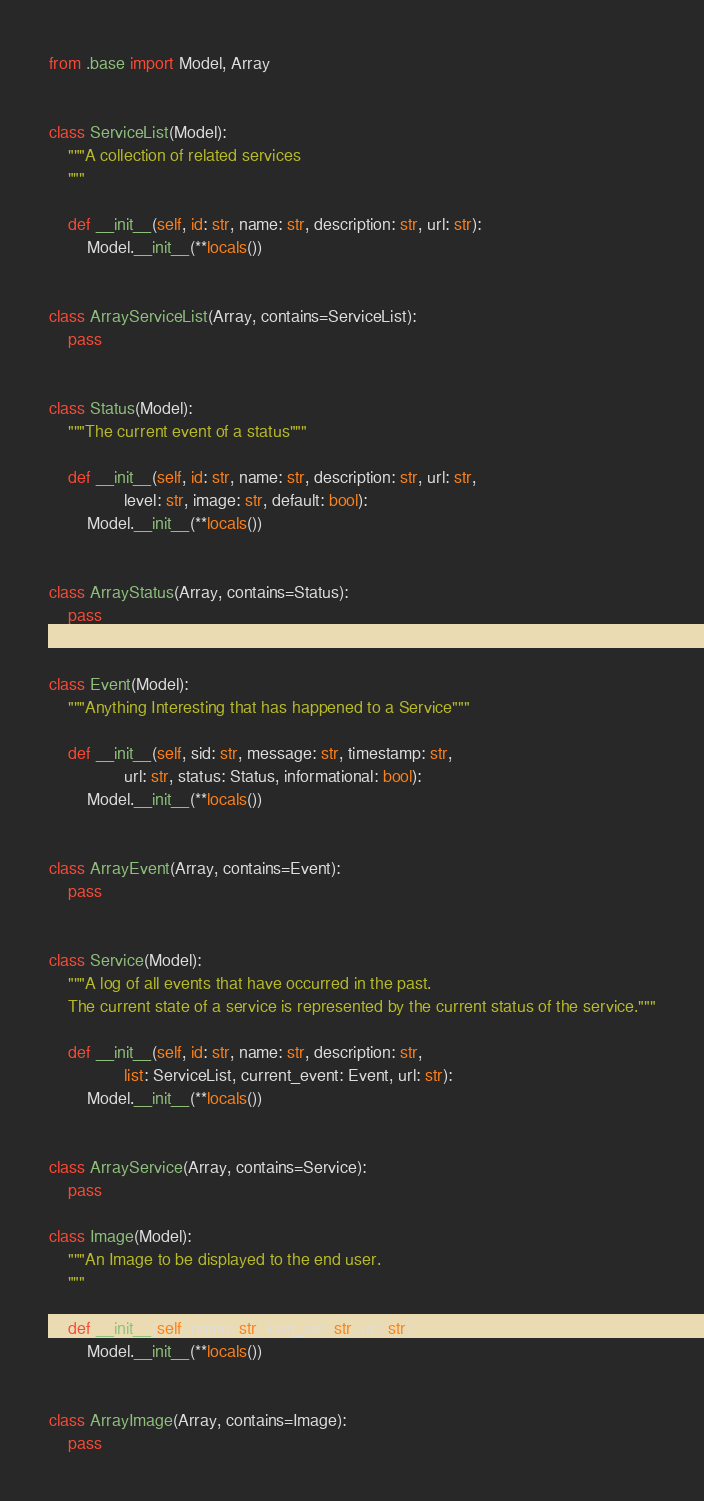<code> <loc_0><loc_0><loc_500><loc_500><_Python_>from .base import Model, Array


class ServiceList(Model):
    """A collection of related services
    """

    def __init__(self, id: str, name: str, description: str, url: str):
        Model.__init__(**locals())


class ArrayServiceList(Array, contains=ServiceList):
    pass


class Status(Model):
    """The current event of a status"""

    def __init__(self, id: str, name: str, description: str, url: str,
                level: str, image: str, default: bool):
        Model.__init__(**locals())


class ArrayStatus(Array, contains=Status):
    pass


class Event(Model):
    """Anything Interesting that has happened to a Service"""

    def __init__(self, sid: str, message: str, timestamp: str,
                url: str, status: Status, informational: bool):
        Model.__init__(**locals())


class ArrayEvent(Array, contains=Event):
    pass


class Service(Model):
    """A log of all events that have occurred in the past.
    The current state of a service is represented by the current status of the service."""

    def __init__(self, id: str, name: str, description: str,
                list: ServiceList, current_event: Event, url: str):
        Model.__init__(**locals())


class ArrayService(Array, contains=Service):
    pass

class Image(Model):
    """An Image to be displayed to the end user.
    """

    def __init__(self, name: str, icon_set: str, url: str):
        Model.__init__(**locals())


class ArrayImage(Array, contains=Image):
    pass
</code> 